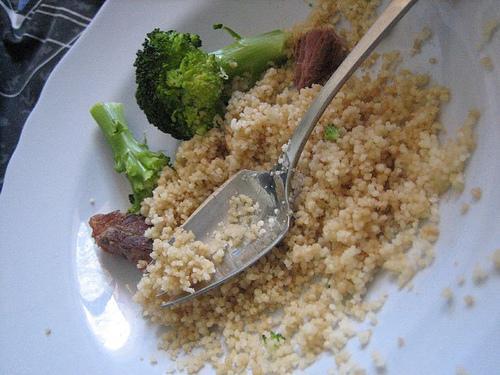How many utensils are visible?
Give a very brief answer. 1. How many pieces of broccoli are visible?
Give a very brief answer. 2. How many utensils are pictured?
Give a very brief answer. 1. How many broccolis are in the photo?
Give a very brief answer. 2. 